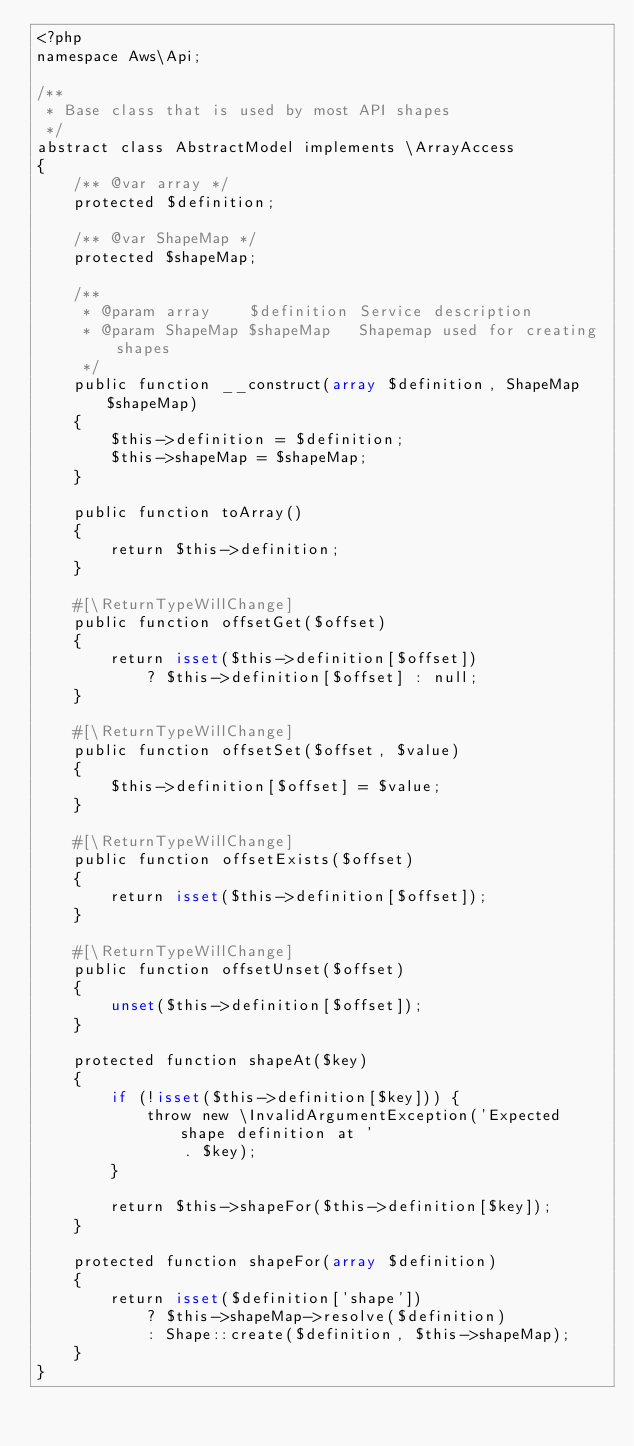<code> <loc_0><loc_0><loc_500><loc_500><_PHP_><?php
namespace Aws\Api;

/**
 * Base class that is used by most API shapes
 */
abstract class AbstractModel implements \ArrayAccess
{
    /** @var array */
    protected $definition;

    /** @var ShapeMap */
    protected $shapeMap;

    /**
     * @param array    $definition Service description
     * @param ShapeMap $shapeMap   Shapemap used for creating shapes
     */
    public function __construct(array $definition, ShapeMap $shapeMap)
    {
        $this->definition = $definition;
        $this->shapeMap = $shapeMap;
    }

    public function toArray()
    {
        return $this->definition;
    }

    #[\ReturnTypeWillChange]
    public function offsetGet($offset)
    {
        return isset($this->definition[$offset])
            ? $this->definition[$offset] : null;
    }

    #[\ReturnTypeWillChange]
    public function offsetSet($offset, $value)
    {
        $this->definition[$offset] = $value;
    }

    #[\ReturnTypeWillChange]
    public function offsetExists($offset)
    {
        return isset($this->definition[$offset]);
    }

    #[\ReturnTypeWillChange]
    public function offsetUnset($offset)
    {
        unset($this->definition[$offset]);
    }

    protected function shapeAt($key)
    {
        if (!isset($this->definition[$key])) {
            throw new \InvalidArgumentException('Expected shape definition at '
                . $key);
        }

        return $this->shapeFor($this->definition[$key]);
    }

    protected function shapeFor(array $definition)
    {
        return isset($definition['shape'])
            ? $this->shapeMap->resolve($definition)
            : Shape::create($definition, $this->shapeMap);
    }
}
</code> 